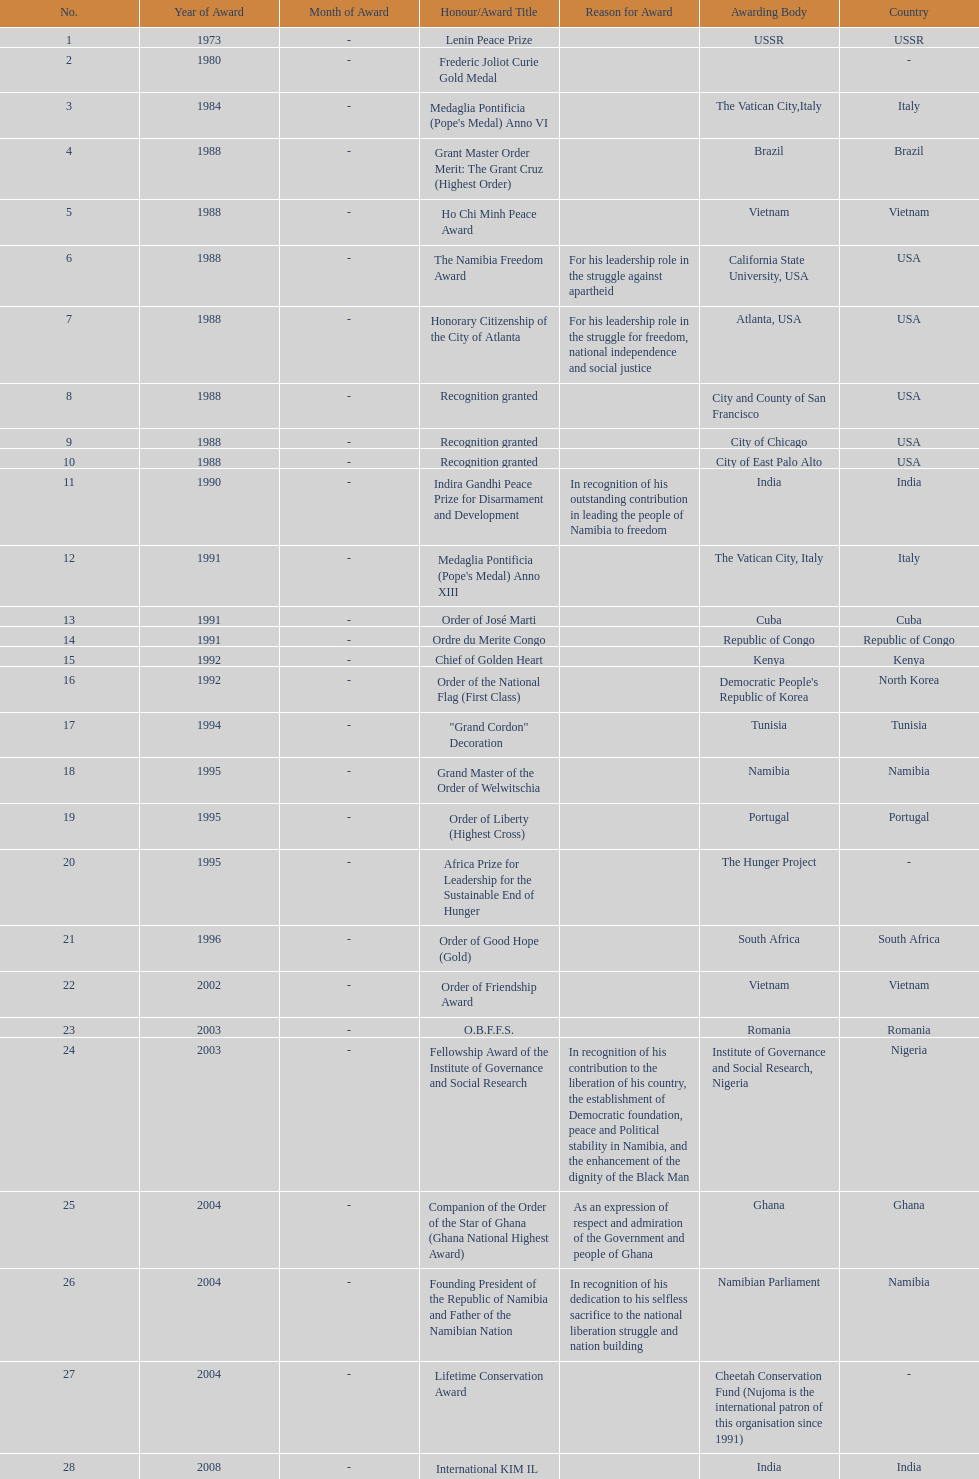What award was won previously just before the medaglia pontificia anno xiii was awarded? Indira Gandhi Peace Prize for Disarmament and Development. 